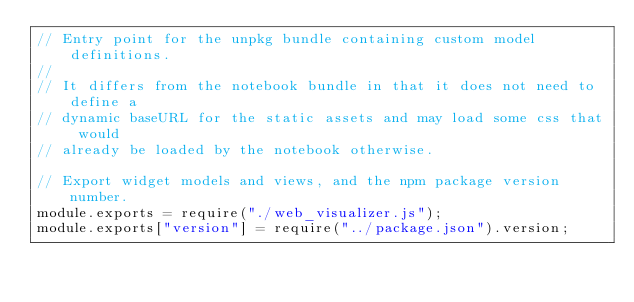<code> <loc_0><loc_0><loc_500><loc_500><_JavaScript_>// Entry point for the unpkg bundle containing custom model definitions.
//
// It differs from the notebook bundle in that it does not need to define a
// dynamic baseURL for the static assets and may load some css that would
// already be loaded by the notebook otherwise.

// Export widget models and views, and the npm package version number.
module.exports = require("./web_visualizer.js");
module.exports["version"] = require("../package.json").version;
</code> 